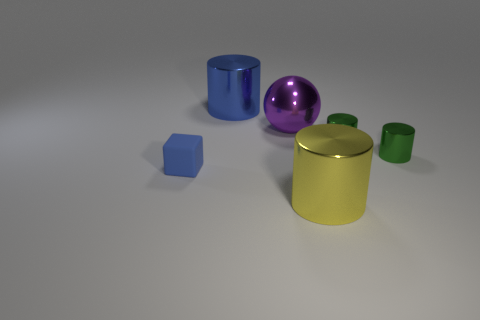What materials are the objects made of? The objects seem to be rendered with different materials. The ball and two cylinders have a shiny, reflective surface, suggesting a metallic finish. The cube and the two smaller cylinders have a more diffused reflection, which could indicate a matte or plastic material. 